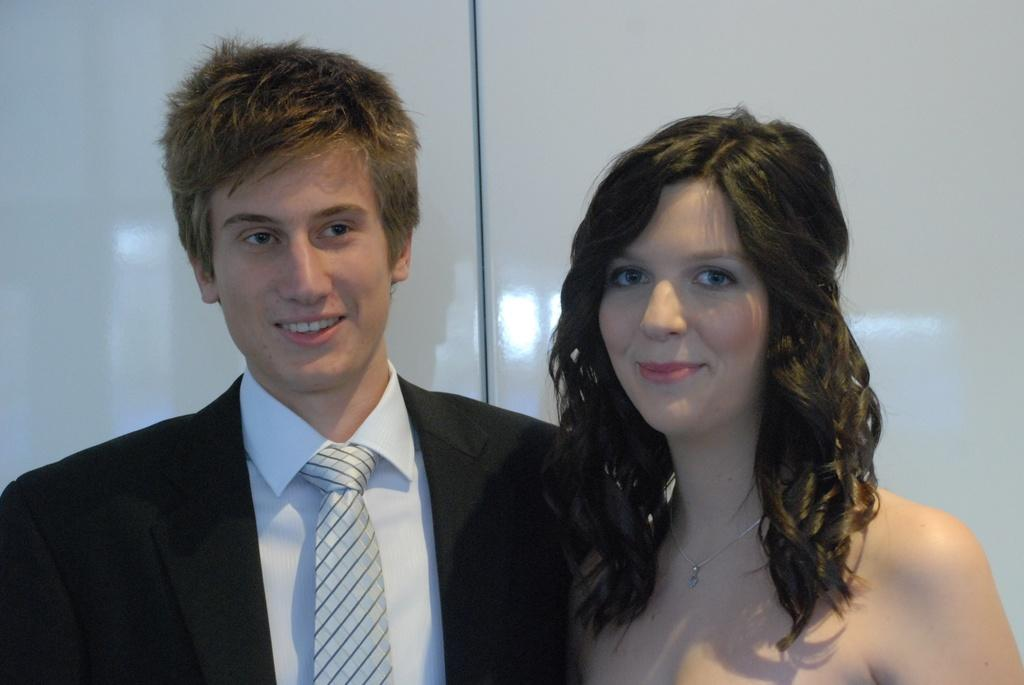How many people are in the image? There is a boy and a girl in the image. What can be seen in the background of the image? The background of the image is white, and there are reflections visible on it. Where is the toothbrush located in the image? There is no toothbrush present in the image. What type of throne is visible in the image? There is no throne present in the image. 